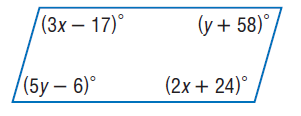Answer the mathemtical geometry problem and directly provide the correct option letter.
Question: Find y so that the quadrilateral is a parallelogram.
Choices: A: 16 B: 32 C: 74 D: 80 A 